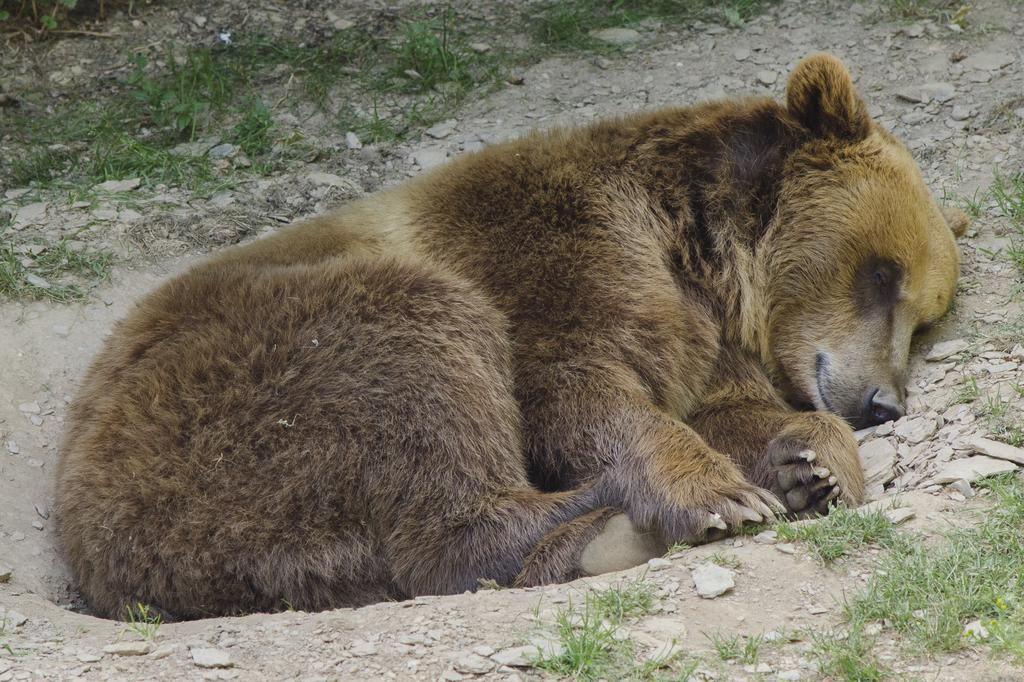What animal is present in the image? There is a bear in the image. What is the bear doing in the image? The bear is sleeping. What type of terrain is visible at the bottom of the image? There is grass and stones on the surface at the bottom of the image. How many minutes does it take for the bear to kiss the amusement park in the image? There is no amusement park or kissing activity present in the image; it features a sleeping bear on a grassy surface with stones. 